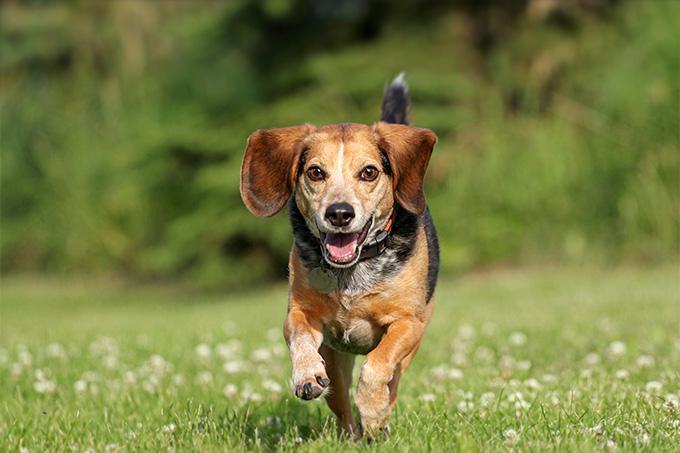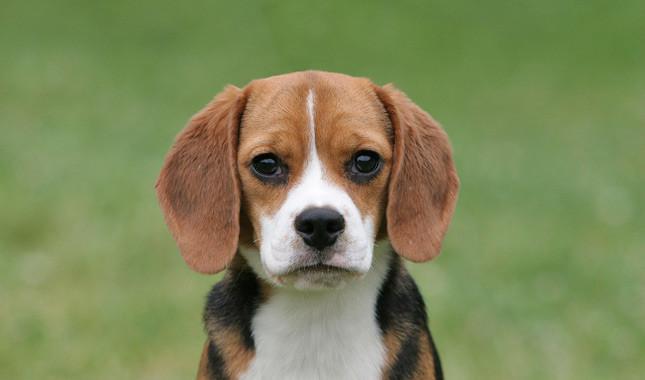The first image is the image on the left, the second image is the image on the right. For the images shown, is this caption "There are more than one beagle in the image on the right" true? Answer yes or no. No. 